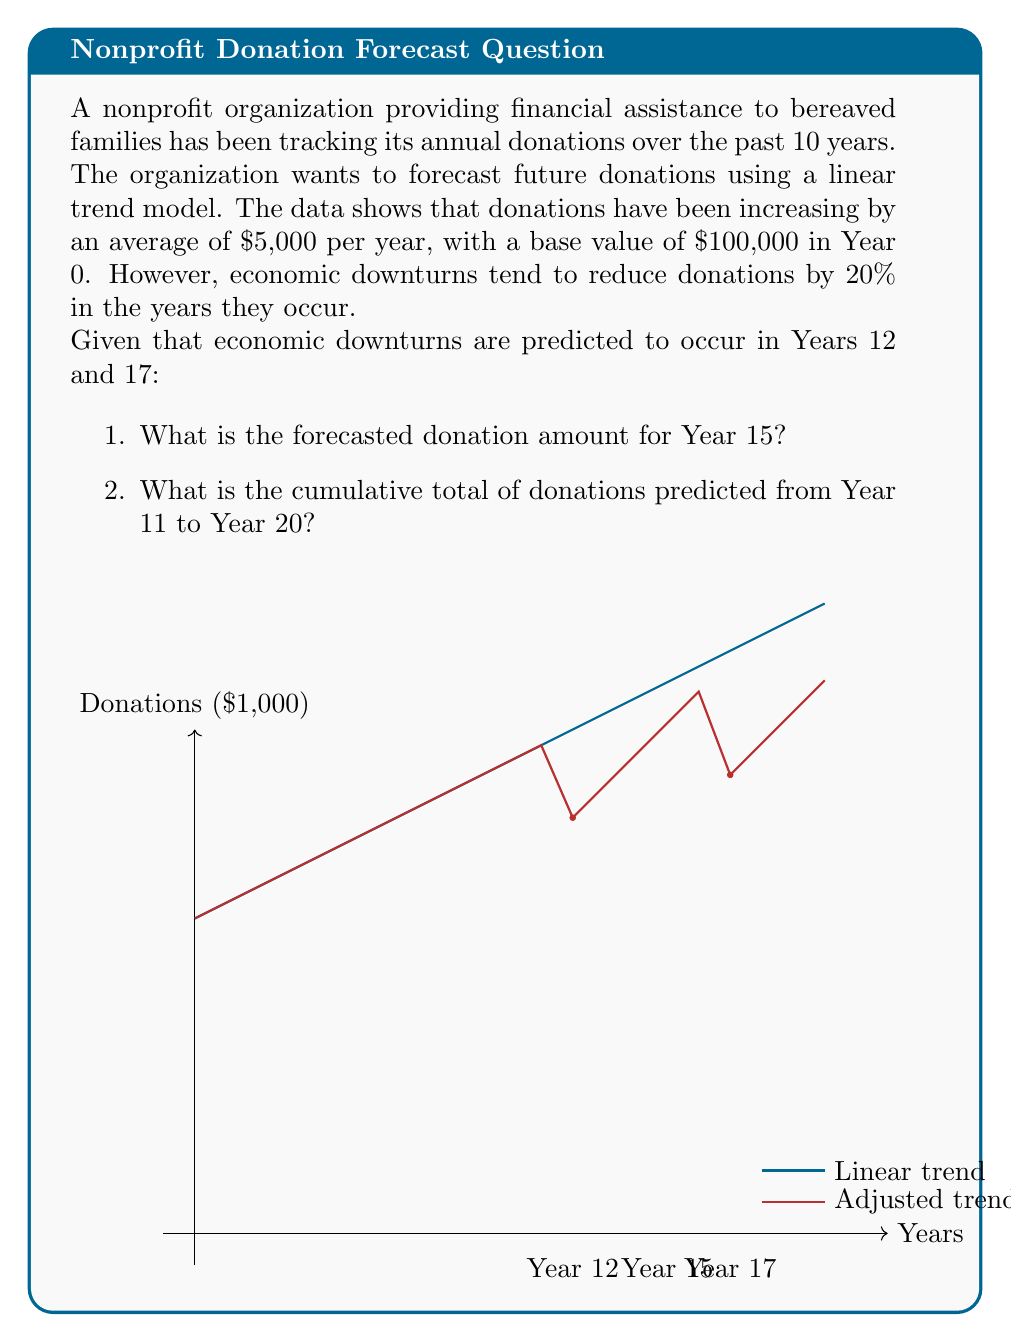Provide a solution to this math problem. Let's approach this problem step-by-step:

1. First, we need to establish the linear trend model:
   $$Y_t = b_0 + b_1t$$
   Where $Y_t$ is the donation amount in year $t$, $b_0$ is the base value, and $b_1$ is the annual increase.
   
   Given: $b_0 = 100,000$ and $b_1 = 5,000$

2. The linear trend model without economic downturns would be:
   $$Y_t = 100,000 + 5,000t$$

3. For Year 15:
   $$Y_{15} = 100,000 + 5,000(15) = 175,000$$

4. However, we need to account for the economic downturn in Year 12:
   Year 12 donation: $160,000 * 0.8 = 128,000$
   
   This creates a new base for subsequent years:
   $$Y_t = 128,000 + 5,000(t-12)$$ for $t > 12$

5. Calculating Year 15 donation with the adjusted model:
   $$Y_{15} = 128,000 + 5,000(15-12) = 143,000$$

6. For the cumulative total from Year 11 to Year 20, we need to:
   a) Calculate normal donations for Years 11, 13-16, 18-20
   b) Calculate reduced donations for Years 12 and 17
   c) Sum all values

7. Normal years:
   Year 11: $155,000
   Year 13-16: 133,000 + 138,000 + 143,000 + 148,000 = 562,000
   Year 18-20: 153,000 + 158,000 + 163,000 = 474,000

8. Downturn years:
   Year 12: $160,000 * 0.8 = 128,000
   Year 17: $185,000 * 0.8 = 148,000

9. Sum of all donations from Year 11 to Year 20:
   $$155,000 + 128,000 + 562,000 + 148,000 + 474,000 = 1,467,000$$
Answer: 1. $143,000
2. $1,467,000 